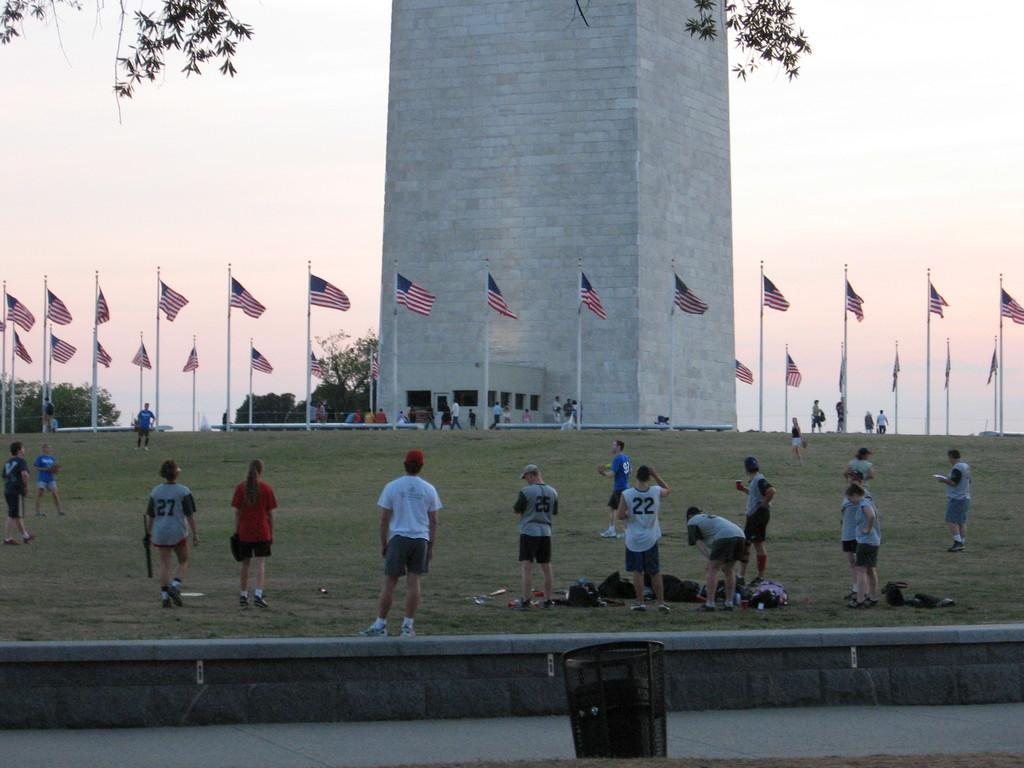How many people are present in the image? There is a group of people standing in the image, but the exact number cannot be determined from the provided facts. What objects are present in the image that are related to flags? There are flags with poles in the image. What type of vegetation can be seen in the image? There are trees in the image. What type of structure is visible in the image? There is a tower in the image. What object is present in the image for waste disposal? There is a dustbin in the image. What items are present in the image that might be used for carrying belongings? There are bags in the image. What can be seen in the background of the image? The sky is visible in the background of the image. What type of kite is being flown near the tower in the image? There is no kite present in the image; it only mentions flags with poles, trees, a tower, a dustbin, bags, and the sky visible in the background. What type of arch is visible in the image? There is no arch present in the image; it only mentions flags with poles, trees, a tower, a dustbin, bags, and the sky visible in the background. 